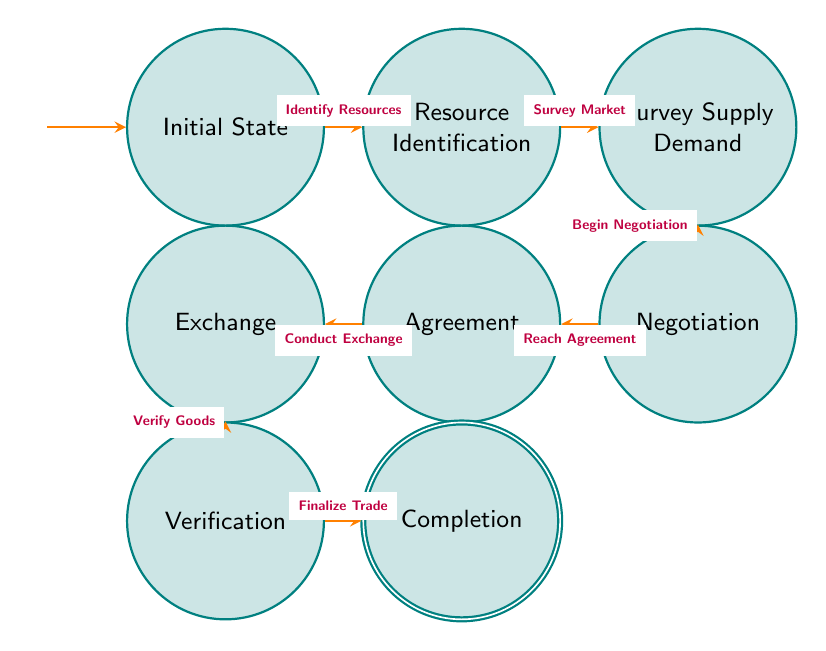What is the starting point of the trade process? The diagram indicates that the trade process begins at the "Initial State," which is the first node in the sequence of the finite state machine.
Answer: Initial State How many nodes are there in the diagram? By counting each state depicted in the diagram, we find there are eight distinct nodes, each representing a step in the trade process.
Answer: 8 What is the final state of the diagram? The last node in the diagram is labeled "Completion," indicating that this is the concluding stage of the trade and barter process.
Answer: Completion What action follows "Survey Supply Demand"? According to the transitions illustrated in the diagram, after "Survey Supply Demand," the next action is "Begin Negotiation," leading to the "Negotiation" state.
Answer: Begin Negotiation What action must be taken to move from "Exchange" to "Verification"? The diagram shows that the transition from "Exchange" to "Verification" occurs when the action "Verify Goods" is taken, confirming the goods exchanged.
Answer: Verify Goods What is the relationship between "Negotiation" and "Agreement"? The relationship is direct, as the transition between the "Negotiation" state and the "Agreement" state is contingent upon the action "Reach Agreement," signaling that terms are discussed and accepted.
Answer: Reach Agreement How many transitions are illustrated in the diagram? The diagram provides a total of seven transitions, each representing a specific action that leads from one state to another within the trade and barter process.
Answer: 7 What is the action that leads to "Resource Identification"? The transition to "Resource Identification" is initiated by the action "Identify Resources," marking the commencement of the trade process.
Answer: Identify Resources What happens after reaching an "Agreement"? After reaching an "Agreement," the next action in the diagram is to "Conduct Exchange," thus facilitating the actual trade of goods between parties.
Answer: Conduct Exchange 